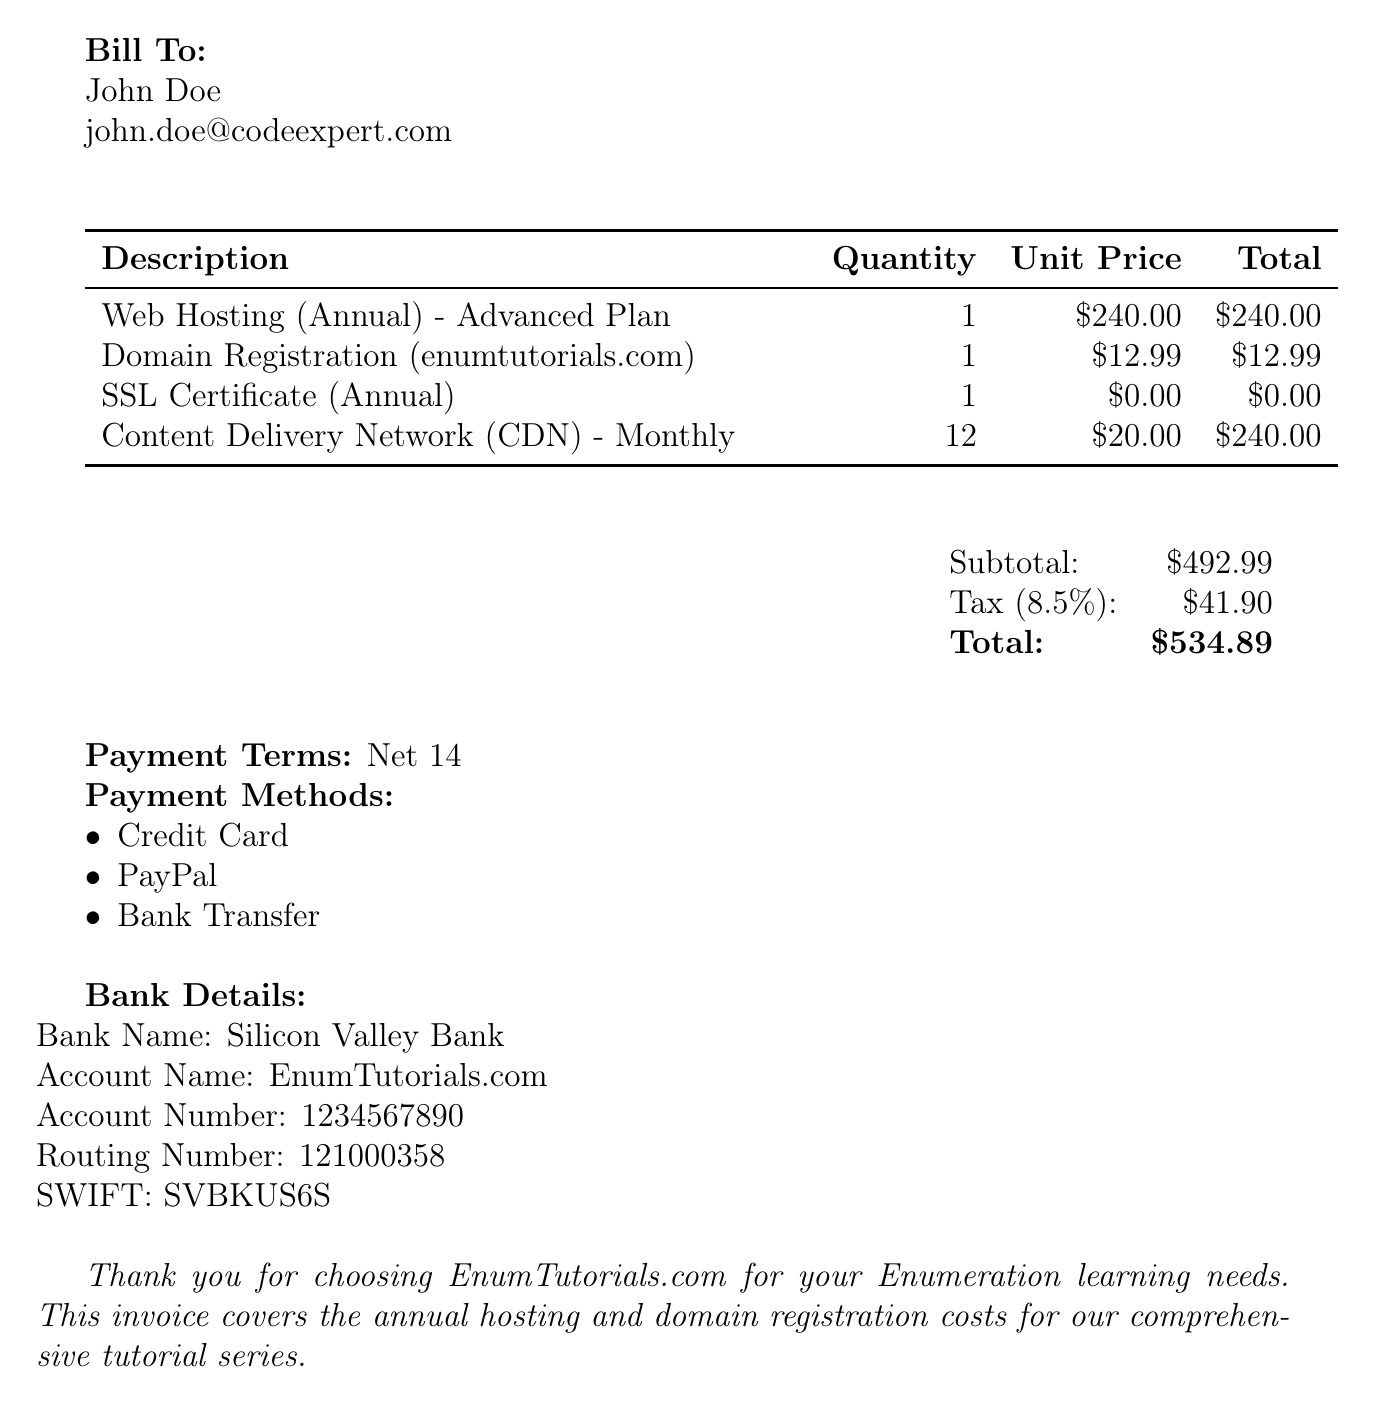What is the invoice number? The invoice number is provided as a reference for tracking billing information in the document.
Answer: INV-2023-0527 Who is the client? The document specifies the client's name, which is important for personalizing communication and record-keeping.
Answer: John Doe What is the total amount due? The total amount due is calculated by adding the subtotal and tax amount, representing the final charge to the client.
Answer: $534.89 What is the due date for payment? The due date indicates when the payment should be made to avoid penalties, essential for cash flow management.
Answer: 2023-06-10 How many items are listed in the invoice? The number of items provides insight into the different services being billed, helping to understand what is being paid for.
Answer: 4 What is the subtotal before tax? The subtotal provides the initial total of all charges before applying taxes, which is necessary for understanding the breakdown of costs.
Answer: $492.99 What is the payment term? Payment terms outline the timeframe for payment and can affect cash flow for the company.
Answer: Net 14 Which payment methods are accepted? Knowing the accepted payment methods allows the client to choose their preferred payment option.
Answer: Credit Card, PayPal, Bank Transfer What is the tax rate applied? The tax rate is vital for understanding how much tax is being charged on the services provided in the invoice.
Answer: 8.5% 